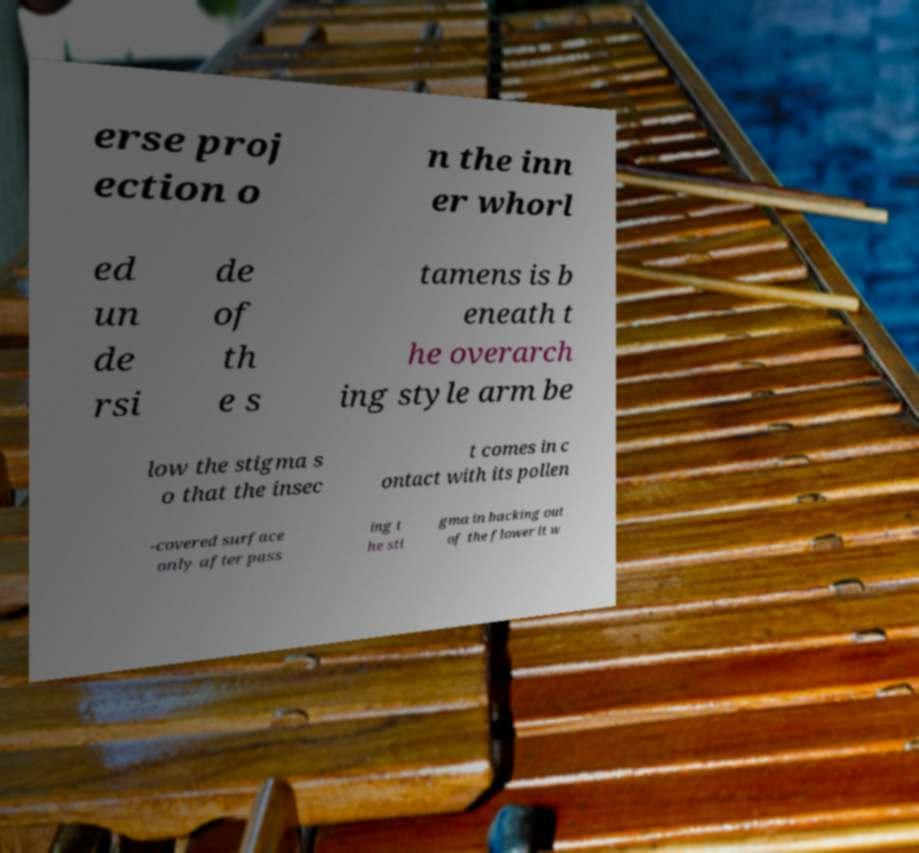Could you extract and type out the text from this image? erse proj ection o n the inn er whorl ed un de rsi de of th e s tamens is b eneath t he overarch ing style arm be low the stigma s o that the insec t comes in c ontact with its pollen -covered surface only after pass ing t he sti gma in backing out of the flower it w 